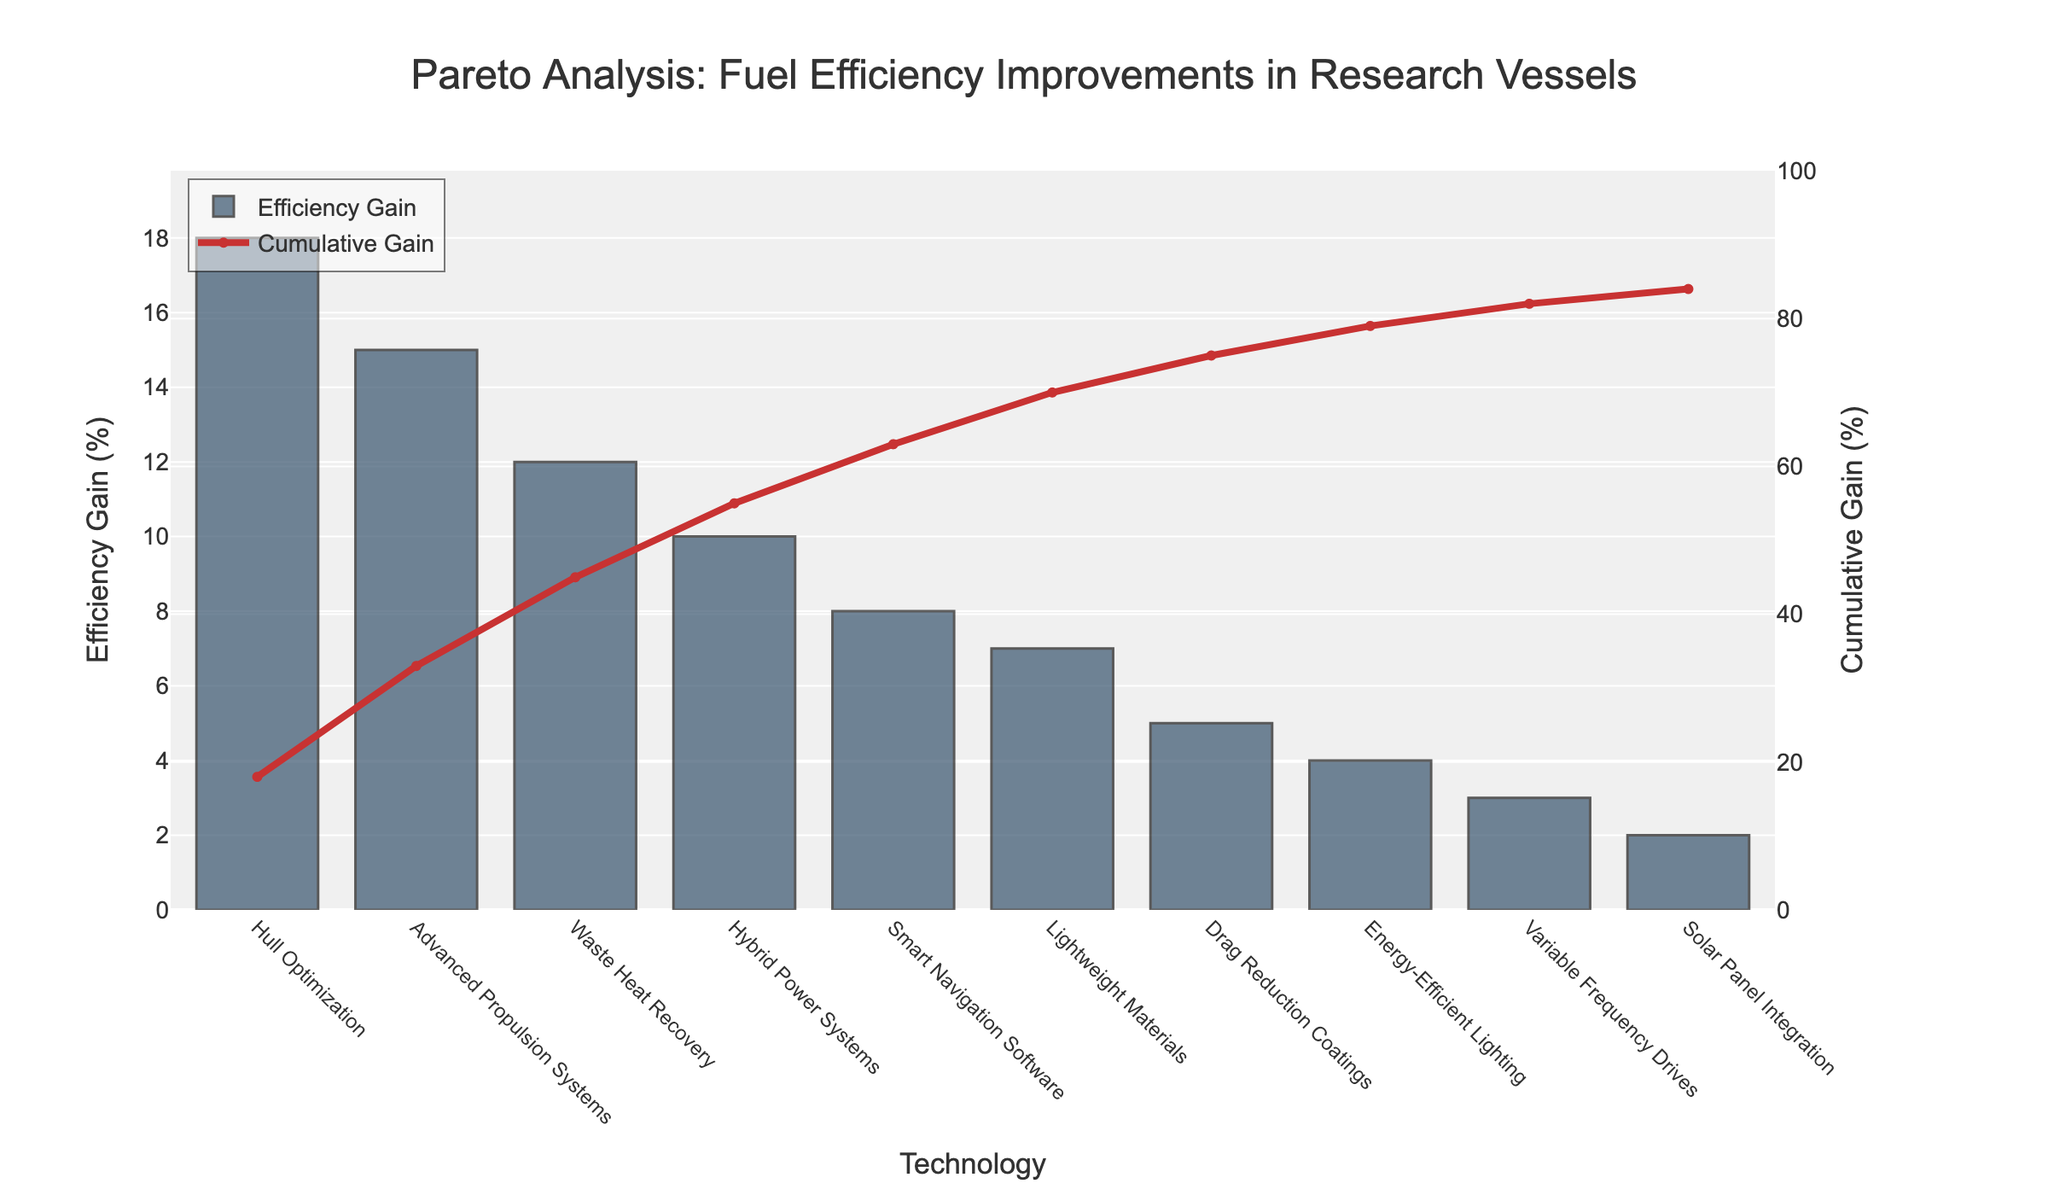Which technology has the highest efficiency gain? By looking at the bar values, Hull Optimization has the tallest bar, representing the highest efficiency gain.
Answer: Hull Optimization What is the cumulative gain percentage after implementing Advanced Propulsion Systems? The figure's line chart for cumulative gain indicates the value where Advanced Propulsion Systems is plotted. It shows 33%.
Answer: 33% How much efficiency gain does Waste Heat Recovery provide? Waste Heat Recovery is the third technology listed on the x-axis, and the corresponding bar height represents an efficiency gain of 12%.
Answer: 12% Which two technologies contribute exactly 10% and 8% efficiency gain, respectively? By examining the bar heights, Hybrid Power Systems contribute 10%, and Smart Navigation Software contributes 8%.
Answer: Hybrid Power Systems, Smart Navigation Software Compare the cumulative gain percentages between Energy-Efficient Lighting and Variable Frequency Drives. Which is higher? Energy-Efficient Lighting is plotted before Variable Frequency Drives; it shows a cumulative gain of 79%. Variable Frequency Drives show 82%, which is higher.
Answer: Variable Frequency Drives Add the efficiency gains of Hybrid Power Systems, Smart Navigation Software, and Lightweight Materials. What is the total? Hybrid Power Systems show 10%, Smart Navigation Software 8%, and Lightweight Materials 7%. Adding them gives 10 + 8 + 7 = 25%.
Answer: 25% What is the cumulative gain percentage when Solar Panel Integration is included? The cumulative gain line intersects with Solar Panel Integration at 84%.
Answer: 84% Which technology has a lower efficiency gain: Drag Reduction Coatings or Variable Frequency Drives? Drag Reduction Coatings shows an efficiency gain of 5% while Variable Frequency Drives shows 3%. Variable Frequency Drives have a lower efficiency gain.
Answer: Variable Frequency Drives What is the total efficiency gain of all technologies combined listed in the chart? Summing up all the efficiency gains: 18 + 15 + 12 + 10 + 8 + 7 + 5 + 4 + 3 + 2 = 84%.
Answer: 84% Identify technology or technologies contributing a cumulative gain beyond 70%. Technologies with cumulative gain percentages after 70% are Drag Reduction Coatings, Energy-Efficient Lighting, Variable Frequency Drives, and Solar Panel Integration.
Answer: Drag Reduction Coatings, Energy-Efficient Lighting, Variable Frequency Drives, Solar Panel Integration 